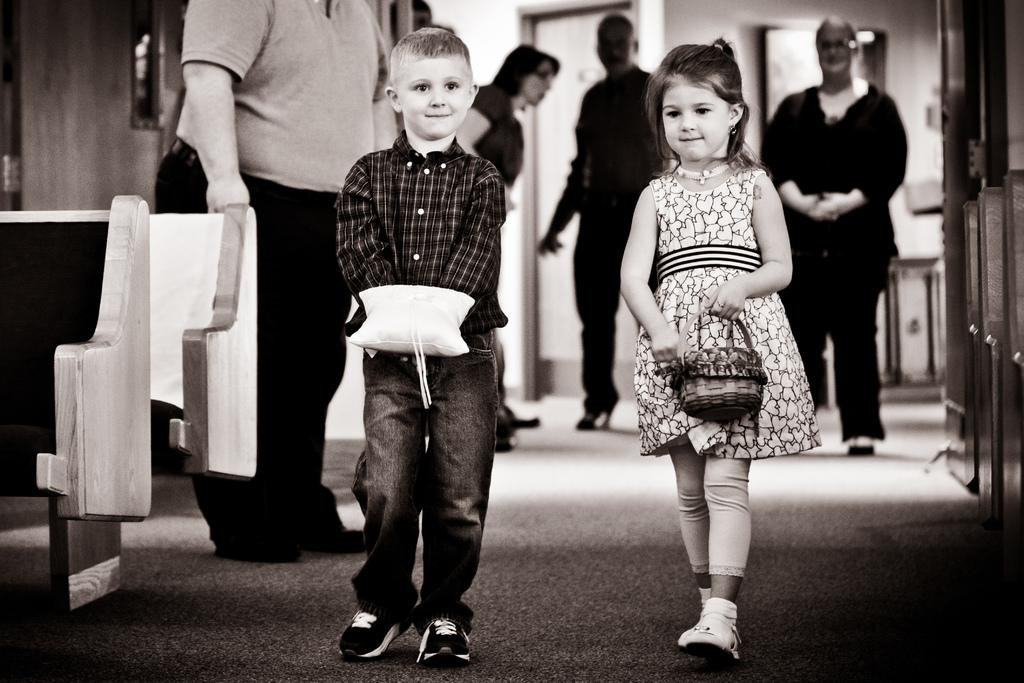What is the girl holding in the image? The girl is holding a basket in the image. What is the boy holding in the image? The boy is holding an object in the image. What type of furniture can be seen in the image? Chairs are visible in the image. How many people are present in the image? There are people in the image. What type of square can be seen in the image? There is no square present in the image. Is the ice melting in the image? There is no ice present in the image, so it cannot be determined if it is melting or not. 